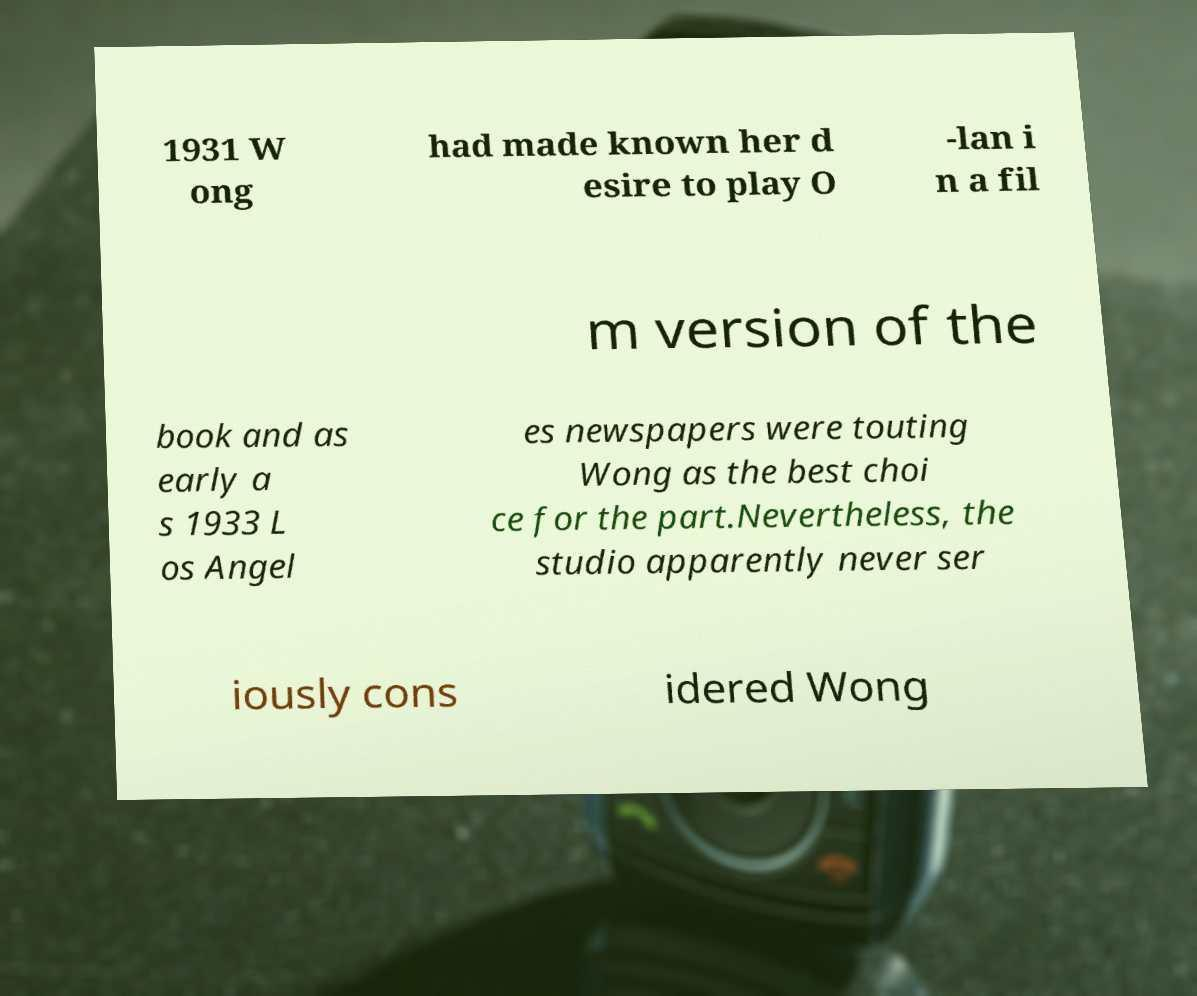There's text embedded in this image that I need extracted. Can you transcribe it verbatim? 1931 W ong had made known her d esire to play O -lan i n a fil m version of the book and as early a s 1933 L os Angel es newspapers were touting Wong as the best choi ce for the part.Nevertheless, the studio apparently never ser iously cons idered Wong 